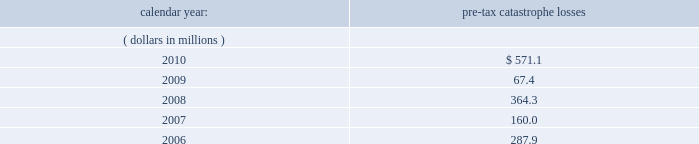United kingdom .
Bermuda re 2019s uk branch conducts business in the uk and is subject to taxation in the uk .
Bermuda re believes that it has operated and will continue to operate its bermuda operation in a manner which will not cause them to be subject to uk taxation .
If bermuda re 2019s bermuda operations were to become subject to uk income tax , there could be a material adverse impact on the company 2019s financial condition , results of operations and cash flow .
Ireland .
Holdings ireland and ireland re conduct business in ireland and are subject to taxation in ireland .
Available information .
The company 2019s annual reports on form 10-k , quarterly reports on form 10-q , current reports on form 8- k , proxy statements and amendments to those reports are available free of charge through the company 2019s internet website at http://www.everestre.com as soon as reasonably practicable after such reports are electronically filed with the securities and exchange commission ( the 201csec 201d ) .
Item 1a .
Risk factors in addition to the other information provided in this report , the following risk factors should be considered when evaluating an investment in our securities .
If the circumstances contemplated by the individual risk factors materialize , our business , financial condition and results of operations could be materially and adversely affected and the trading price of our common shares could decline significantly .
Risks relating to our business fluctuations in the financial markets could result in investment losses .
Prolonged and severe disruptions in the public debt and equity markets , such as occurred during 2008 , could result in significant realized and unrealized losses in our investment portfolio .
For the year ended december 31 , 2008 , we incurred $ 695.8 million of realized investment gains and $ 310.4 million of unrealized investment losses .
Although financial markets significantly improved during 2009 and 2010 , they could deteriorate in the future and again result in substantial realized and unrealized losses , which could have a material adverse impact on our results of operations , equity , business and insurer financial strength and debt ratings .
Our results could be adversely affected by catastrophic events .
We are exposed to unpredictable catastrophic events , including weather-related and other natural catastrophes , as well as acts of terrorism .
Any material reduction in our operating results caused by the occurrence of one or more catastrophes could inhibit our ability to pay dividends or to meet our interest and principal payment obligations .
Subsequent to april 1 , 2010 , we define a catastrophe as an event that causes a loss on property exposures before reinsurance of at least $ 10.0 million , before corporate level reinsurance and taxes .
Prior to april 1 , 2010 , we used a threshold of $ 5.0 million .
By way of illustration , during the past five calendar years , pre-tax catastrophe losses , net of contract specific reinsurance but before cessions under corporate reinsurance programs , were as follows: .

What was the ratio of the pre-tax catastrophe losses in 2010 compared to 2009? 
Computations: (571.1 / 67.4)
Answer: 8.47329. United kingdom .
Bermuda re 2019s uk branch conducts business in the uk and is subject to taxation in the uk .
Bermuda re believes that it has operated and will continue to operate its bermuda operation in a manner which will not cause them to be subject to uk taxation .
If bermuda re 2019s bermuda operations were to become subject to uk income tax , there could be a material adverse impact on the company 2019s financial condition , results of operations and cash flow .
Ireland .
Holdings ireland and ireland re conduct business in ireland and are subject to taxation in ireland .
Available information .
The company 2019s annual reports on form 10-k , quarterly reports on form 10-q , current reports on form 8- k , proxy statements and amendments to those reports are available free of charge through the company 2019s internet website at http://www.everestre.com as soon as reasonably practicable after such reports are electronically filed with the securities and exchange commission ( the 201csec 201d ) .
Item 1a .
Risk factors in addition to the other information provided in this report , the following risk factors should be considered when evaluating an investment in our securities .
If the circumstances contemplated by the individual risk factors materialize , our business , financial condition and results of operations could be materially and adversely affected and the trading price of our common shares could decline significantly .
Risks relating to our business fluctuations in the financial markets could result in investment losses .
Prolonged and severe disruptions in the public debt and equity markets , such as occurred during 2008 , could result in significant realized and unrealized losses in our investment portfolio .
For the year ended december 31 , 2008 , we incurred $ 695.8 million of realized investment gains and $ 310.4 million of unrealized investment losses .
Although financial markets significantly improved during 2009 and 2010 , they could deteriorate in the future and again result in substantial realized and unrealized losses , which could have a material adverse impact on our results of operations , equity , business and insurer financial strength and debt ratings .
Our results could be adversely affected by catastrophic events .
We are exposed to unpredictable catastrophic events , including weather-related and other natural catastrophes , as well as acts of terrorism .
Any material reduction in our operating results caused by the occurrence of one or more catastrophes could inhibit our ability to pay dividends or to meet our interest and principal payment obligations .
Subsequent to april 1 , 2010 , we define a catastrophe as an event that causes a loss on property exposures before reinsurance of at least $ 10.0 million , before corporate level reinsurance and taxes .
Prior to april 1 , 2010 , we used a threshold of $ 5.0 million .
By way of illustration , during the past five calendar years , pre-tax catastrophe losses , net of contract specific reinsurance but before cessions under corporate reinsurance programs , were as follows: .

In 2008 what was the ratio of the realized investment gains to the unrealized investment losses .? 
Computations: (695.8 / 310.4)
Answer: 2.24162. 